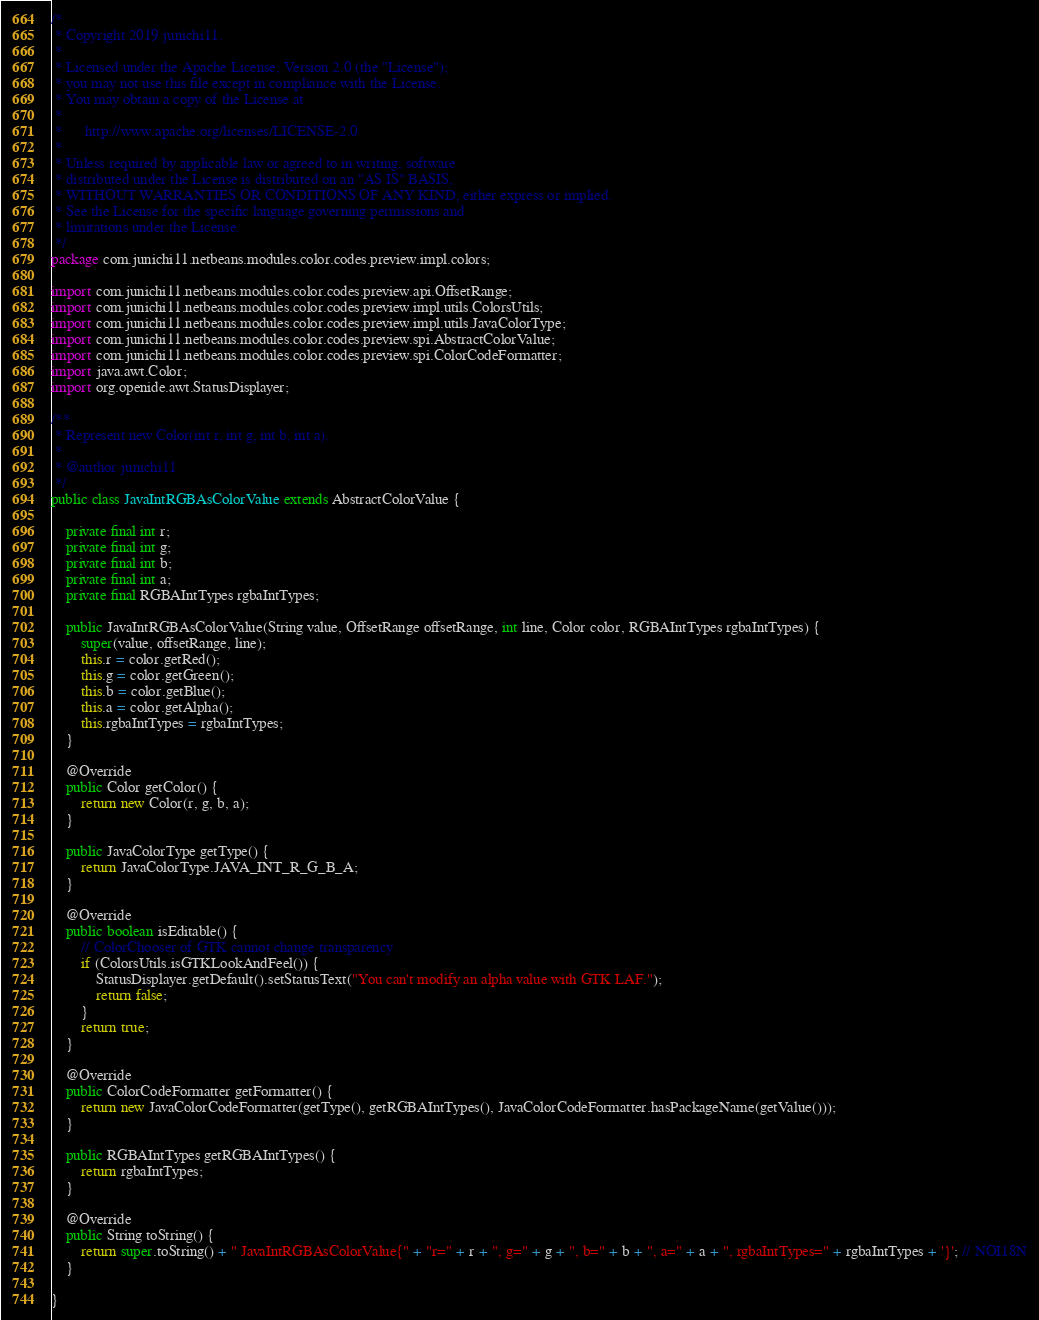Convert code to text. <code><loc_0><loc_0><loc_500><loc_500><_Java_>/*
 * Copyright 2019 junichi11.
 *
 * Licensed under the Apache License, Version 2.0 (the "License");
 * you may not use this file except in compliance with the License.
 * You may obtain a copy of the License at
 *
 *      http://www.apache.org/licenses/LICENSE-2.0
 *
 * Unless required by applicable law or agreed to in writing, software
 * distributed under the License is distributed on an "AS IS" BASIS,
 * WITHOUT WARRANTIES OR CONDITIONS OF ANY KIND, either express or implied.
 * See the License for the specific language governing permissions and
 * limitations under the License.
 */
package com.junichi11.netbeans.modules.color.codes.preview.impl.colors;

import com.junichi11.netbeans.modules.color.codes.preview.api.OffsetRange;
import com.junichi11.netbeans.modules.color.codes.preview.impl.utils.ColorsUtils;
import com.junichi11.netbeans.modules.color.codes.preview.impl.utils.JavaColorType;
import com.junichi11.netbeans.modules.color.codes.preview.spi.AbstractColorValue;
import com.junichi11.netbeans.modules.color.codes.preview.spi.ColorCodeFormatter;
import java.awt.Color;
import org.openide.awt.StatusDisplayer;

/**
 * Represent new Color(int r, int g, int b, int a).
 *
 * @author junichi11
 */
public class JavaIntRGBAsColorValue extends AbstractColorValue {

    private final int r;
    private final int g;
    private final int b;
    private final int a;
    private final RGBAIntTypes rgbaIntTypes;

    public JavaIntRGBAsColorValue(String value, OffsetRange offsetRange, int line, Color color, RGBAIntTypes rgbaIntTypes) {
        super(value, offsetRange, line);
        this.r = color.getRed();
        this.g = color.getGreen();
        this.b = color.getBlue();
        this.a = color.getAlpha();
        this.rgbaIntTypes = rgbaIntTypes;
    }

    @Override
    public Color getColor() {
        return new Color(r, g, b, a);
    }

    public JavaColorType getType() {
        return JavaColorType.JAVA_INT_R_G_B_A;
    }

    @Override
    public boolean isEditable() {
        // ColorChooser of GTK cannot change transparency
        if (ColorsUtils.isGTKLookAndFeel()) {
            StatusDisplayer.getDefault().setStatusText("You can't modify an alpha value with GTK LAF.");
            return false;
        }
        return true;
    }

    @Override
    public ColorCodeFormatter getFormatter() {
        return new JavaColorCodeFormatter(getType(), getRGBAIntTypes(), JavaColorCodeFormatter.hasPackageName(getValue()));
    }

    public RGBAIntTypes getRGBAIntTypes() {
        return rgbaIntTypes;
    }

    @Override
    public String toString() {
        return super.toString() + " JavaIntRGBAsColorValue{" + "r=" + r + ", g=" + g + ", b=" + b + ", a=" + a + ", rgbaIntTypes=" + rgbaIntTypes + '}'; // NOI18N
    }

}
</code> 